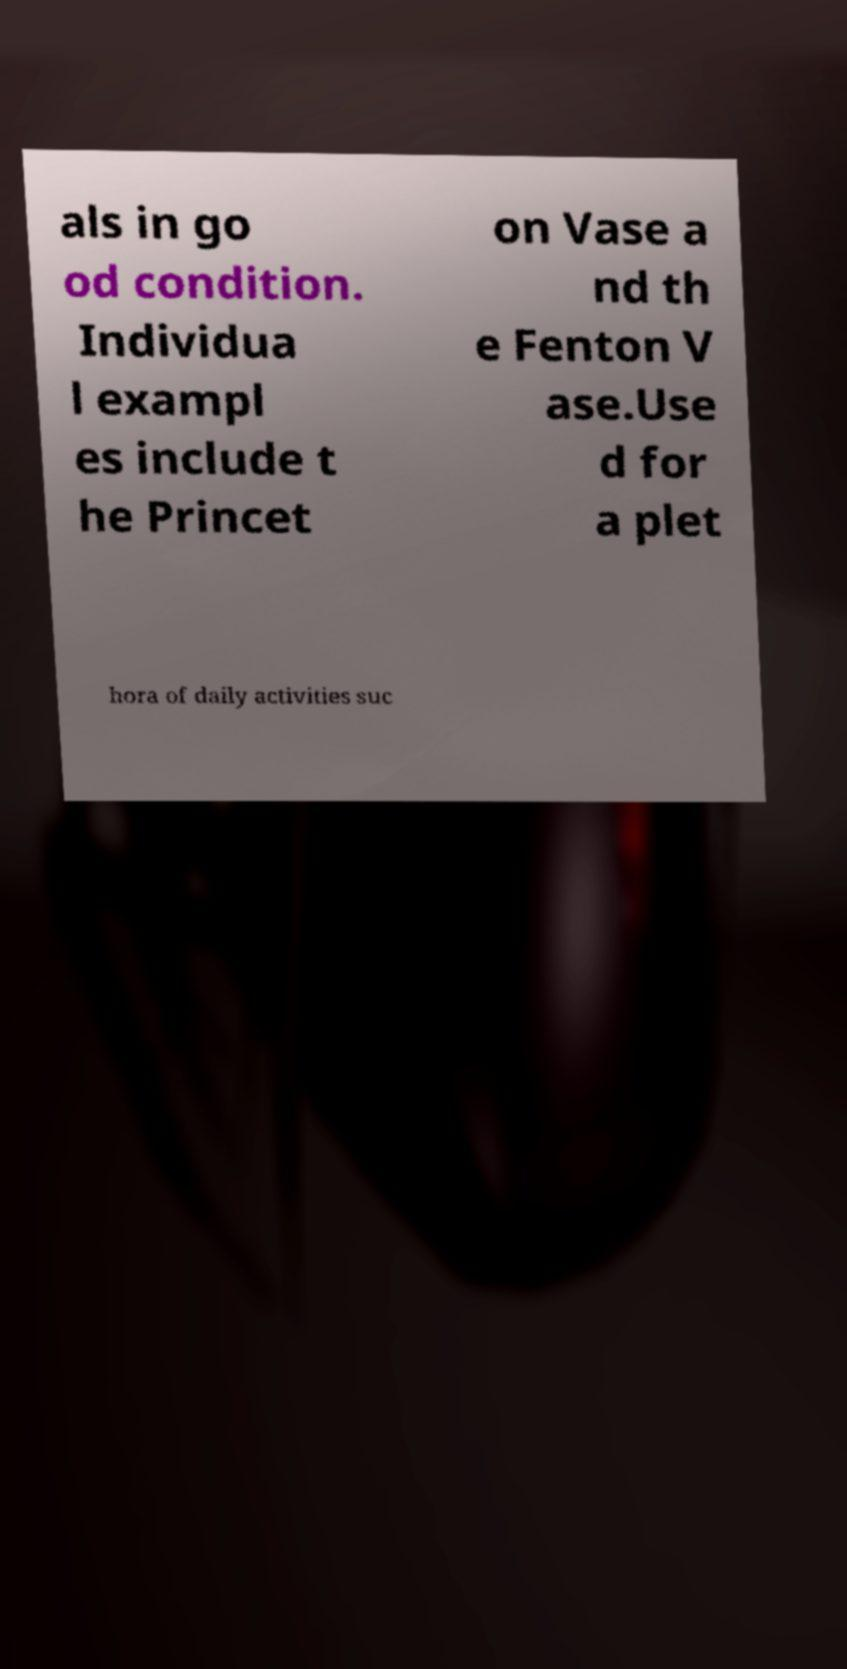I need the written content from this picture converted into text. Can you do that? als in go od condition. Individua l exampl es include t he Princet on Vase a nd th e Fenton V ase.Use d for a plet hora of daily activities suc 